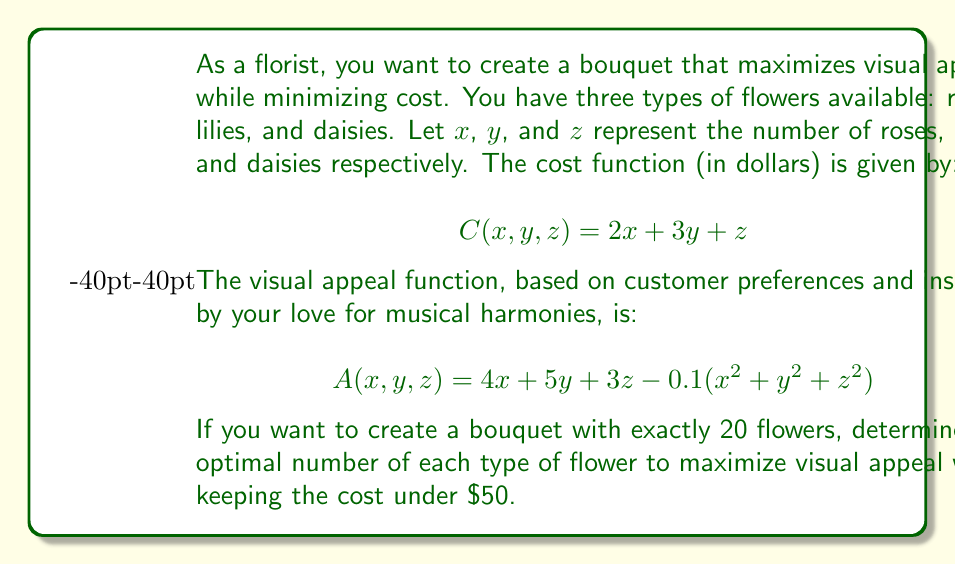Teach me how to tackle this problem. To solve this optimization problem, we'll use the method of Lagrange multipliers. Let's follow these steps:

1) First, we set up our constraints:
   $g_1(x,y,z) = x + y + z - 20 = 0$ (total flowers constraint)
   $g_2(x,y,z) = 2x + 3y + z - 50 \leq 0$ (cost constraint)

2) We form the Lagrangian function:
   $$L(x,y,z,\lambda_1,\lambda_2) = A(x,y,z) + \lambda_1g_1(x,y,z) + \lambda_2g_2(x,y,z)$$
   $$L = 4x + 5y + 3z - 0.1(x^2 + y^2 + z^2) + \lambda_1(x + y + z - 20) + \lambda_2(2x + 3y + z - 50)$$

3) We take partial derivatives and set them to zero:
   $$\frac{\partial L}{\partial x} = 4 - 0.2x + \lambda_1 + 2\lambda_2 = 0$$
   $$\frac{\partial L}{\partial y} = 5 - 0.2y + \lambda_1 + 3\lambda_2 = 0$$
   $$\frac{\partial L}{\partial z} = 3 - 0.2z + \lambda_1 + \lambda_2 = 0$$
   $$\frac{\partial L}{\partial \lambda_1} = x + y + z - 20 = 0$$
   $$\frac{\partial L}{\partial \lambda_2} = 2x + 3y + z - 50 = 0$$

4) Solving this system of equations:
   From the first three equations:
   $x = 20 - 5\lambda_2$
   $y = 25 - 10\lambda_2$
   $z = 15 + 5\lambda_2$

5) Substituting these into the fourth equation:
   $(20 - 5\lambda_2) + (25 - 10\lambda_2) + (15 + 5\lambda_2) = 20$
   $60 - 10\lambda_2 = 20$
   $\lambda_2 = 4$

6) Now we can solve for x, y, and z:
   $x = 20 - 5(4) = 0$
   $y = 25 - 10(4) = -15$ (invalid)
   $z = 15 + 5(4) = 35$

7) Since we got an invalid solution, we need to consider the boundary of the cost constraint:
   $2x + 3y + z = 50$

8) Solving the system:
   $x + y + z = 20$
   $2x + 3y + z = 50$
   
   Subtracting the first equation from the second:
   $x + 2y = 30$

9) Try integer solutions:
   If $x = 10$, then $y = 10$ and $z = 0$
   If $x = 8$, then $y = 11$ and $z = 1$
   If $x = 6$, then $y = 12$ and $z = 2$

10) Calculate the appeal for each:
    For (10, 10, 0): $A = 85$
    For (8, 11, 1): $A = 86.9$
    For (6, 12, 2): $A = 87.6$

Therefore, the optimal arrangement is 6 roses, 12 lilies, and 2 daisies.
Answer: The optimal arrangement is 6 roses, 12 lilies, and 2 daisies, which maximizes visual appeal at 87.6 while keeping the cost at exactly $50. 